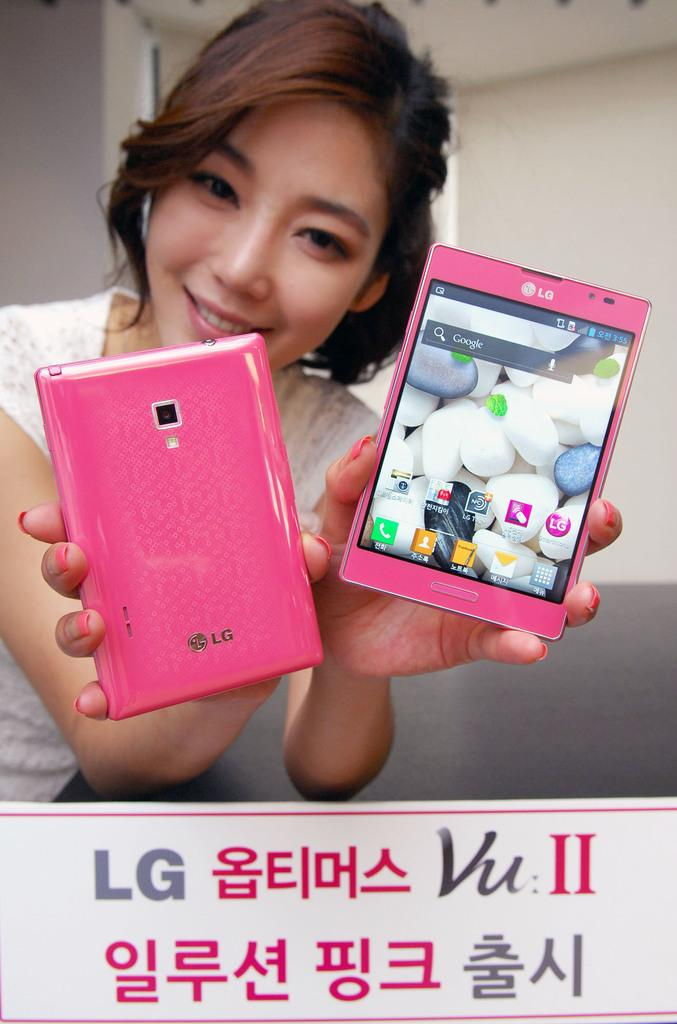What is the woman in the image wearing? The woman is wearing a white shirt. What is the woman's facial expression in the image? The woman is smiling. What is the woman holding in the image? The woman is holding two pink mobile phones. What is in front of the woman in the image? There is a black table in front of the woman. What can be seen in the background of the image? There is a white wall in the background of the image. How many babies are visible in the image? There are no babies visible in the image; it features a woman holding two pink mobile phones. What type of vest is the woman wearing in the image? The woman is not wearing a vest in the image; she is wearing a white shirt. 